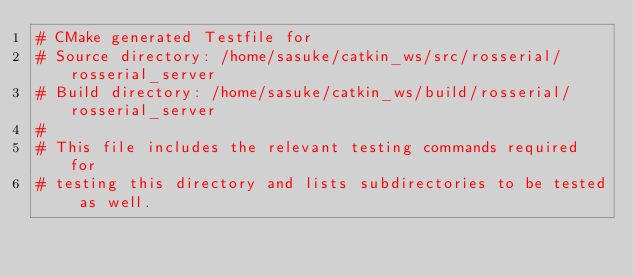Convert code to text. <code><loc_0><loc_0><loc_500><loc_500><_CMake_># CMake generated Testfile for 
# Source directory: /home/sasuke/catkin_ws/src/rosserial/rosserial_server
# Build directory: /home/sasuke/catkin_ws/build/rosserial/rosserial_server
# 
# This file includes the relevant testing commands required for 
# testing this directory and lists subdirectories to be tested as well.
</code> 